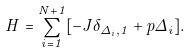<formula> <loc_0><loc_0><loc_500><loc_500>H = \sum _ { i = 1 } ^ { N + 1 } [ - J \delta _ { \Delta _ { i } , 1 } + p \Delta _ { i } ] .</formula> 